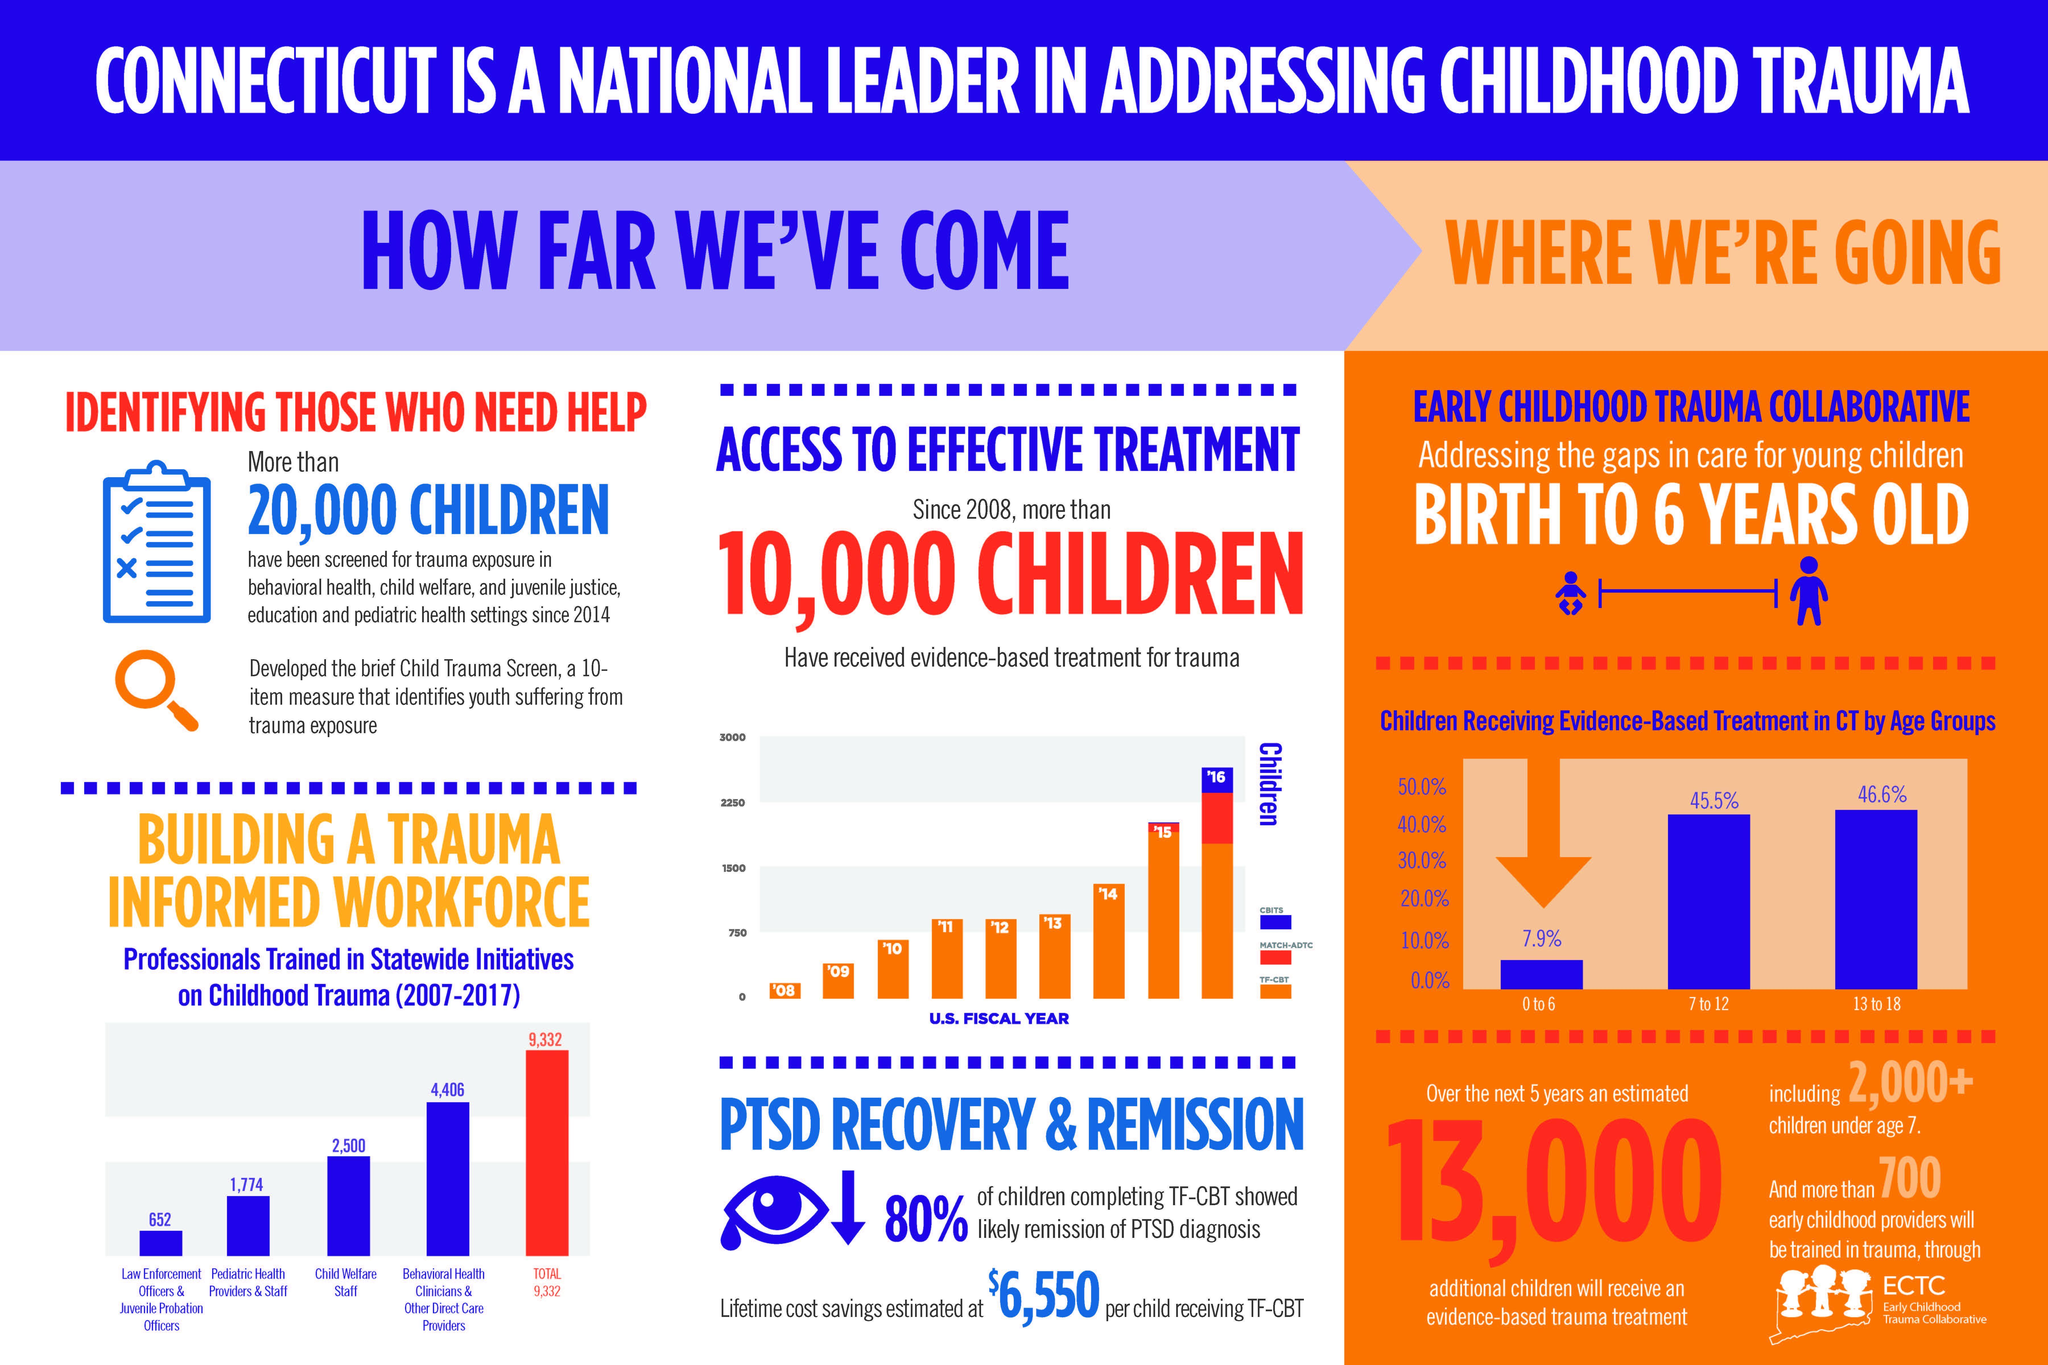What is total number of professional trained as behavioral health clinicians and pediatric health providers?
Answer the question with a short phrase. 6,180 Which age group of children receive the second highest percentage of evidence based treatment ? 7 to 12 